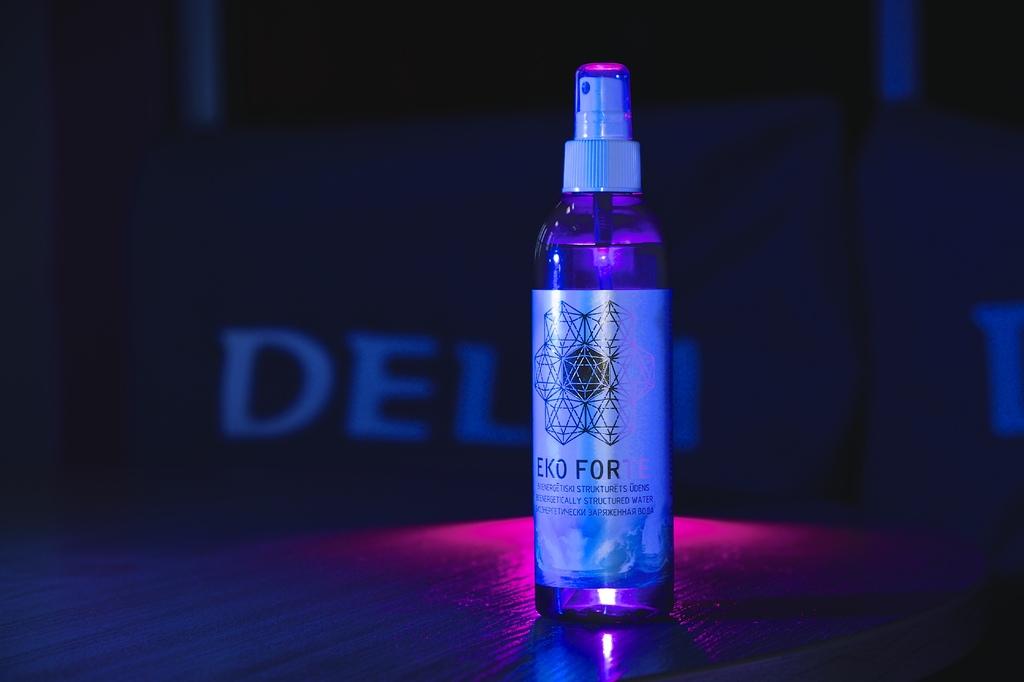What kind of forte?
Provide a short and direct response. Eko. What are the first three letters on sign in the background?
Your response must be concise. Del. 